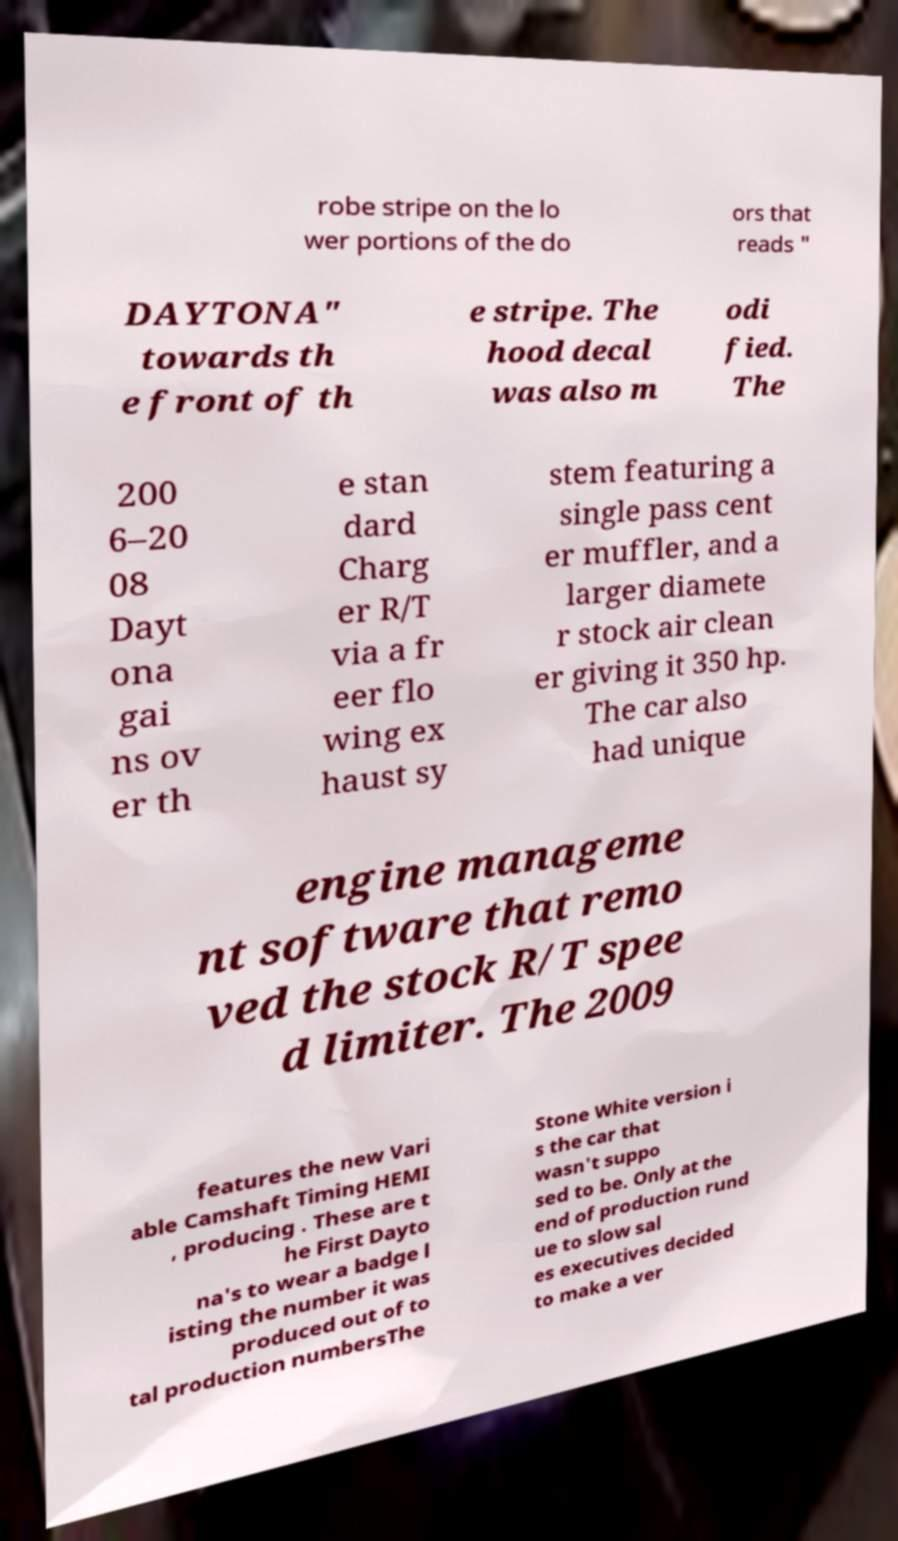Please identify and transcribe the text found in this image. robe stripe on the lo wer portions of the do ors that reads " DAYTONA" towards th e front of th e stripe. The hood decal was also m odi fied. The 200 6–20 08 Dayt ona gai ns ov er th e stan dard Charg er R/T via a fr eer flo wing ex haust sy stem featuring a single pass cent er muffler, and a larger diamete r stock air clean er giving it 350 hp. The car also had unique engine manageme nt software that remo ved the stock R/T spee d limiter. The 2009 features the new Vari able Camshaft Timing HEMI , producing . These are t he First Dayto na's to wear a badge l isting the number it was produced out of to tal production numbersThe Stone White version i s the car that wasn't suppo sed to be. Only at the end of production rund ue to slow sal es executives decided to make a ver 